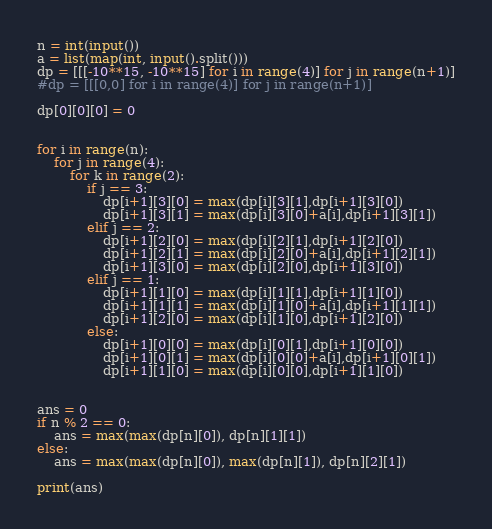Convert code to text. <code><loc_0><loc_0><loc_500><loc_500><_Python_>n = int(input())
a = list(map(int, input().split()))
dp = [[[-10**15, -10**15] for i in range(4)] for j in range(n+1)]
#dp = [[[0,0] for i in range(4)] for j in range(n+1)]

dp[0][0][0] = 0


for i in range(n):
    for j in range(4):
        for k in range(2):
            if j == 3:
                dp[i+1][3][0] = max(dp[i][3][1],dp[i+1][3][0])
                dp[i+1][3][1] = max(dp[i][3][0]+a[i],dp[i+1][3][1])
            elif j == 2:
                dp[i+1][2][0] = max(dp[i][2][1],dp[i+1][2][0])
                dp[i+1][2][1] = max(dp[i][2][0]+a[i],dp[i+1][2][1])
                dp[i+1][3][0] = max(dp[i][2][0],dp[i+1][3][0])
            elif j == 1:
                dp[i+1][1][0] = max(dp[i][1][1],dp[i+1][1][0])
                dp[i+1][1][1] = max(dp[i][1][0]+a[i],dp[i+1][1][1])
                dp[i+1][2][0] = max(dp[i][1][0],dp[i+1][2][0])
            else:
                dp[i+1][0][0] = max(dp[i][0][1],dp[i+1][0][0])
                dp[i+1][0][1] = max(dp[i][0][0]+a[i],dp[i+1][0][1])
                dp[i+1][1][0] = max(dp[i][0][0],dp[i+1][1][0])


ans = 0
if n % 2 == 0:
    ans = max(max(dp[n][0]), dp[n][1][1])
else:
    ans = max(max(dp[n][0]), max(dp[n][1]), dp[n][2][1])

print(ans)
</code> 